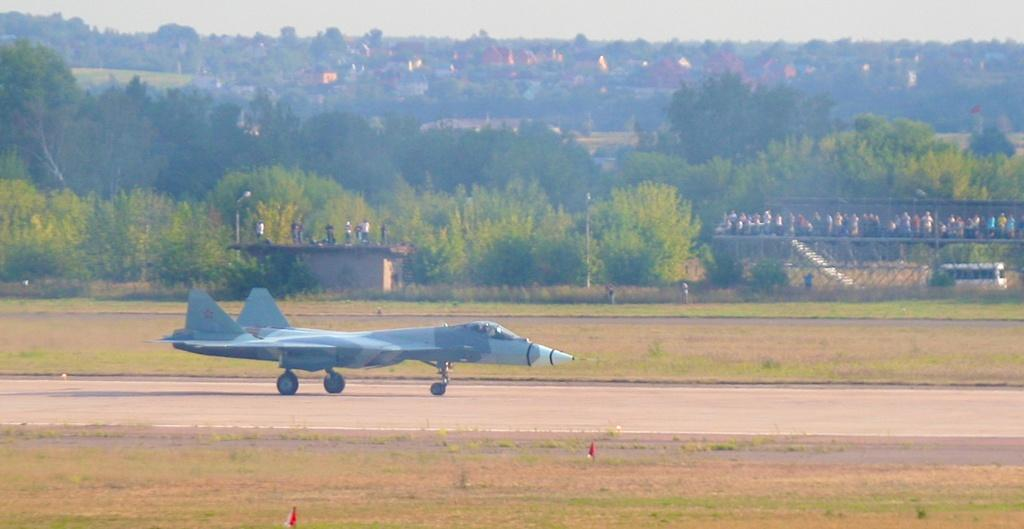What is the main subject of the image? The main subject of the image is an airplane on the ground. What can be seen in the background of the image? There are trees, buildings, and the sky visible in the background of the image. Where are the people located in the image? The people are on a bridge in the image. What type of advertisement can be seen on the airplane in the image? There is no advertisement visible on the airplane in the image. What suggestion can be made to improve the image? The question is not relevant to the image, as it does not ask for a specific detail or fact about the image. 